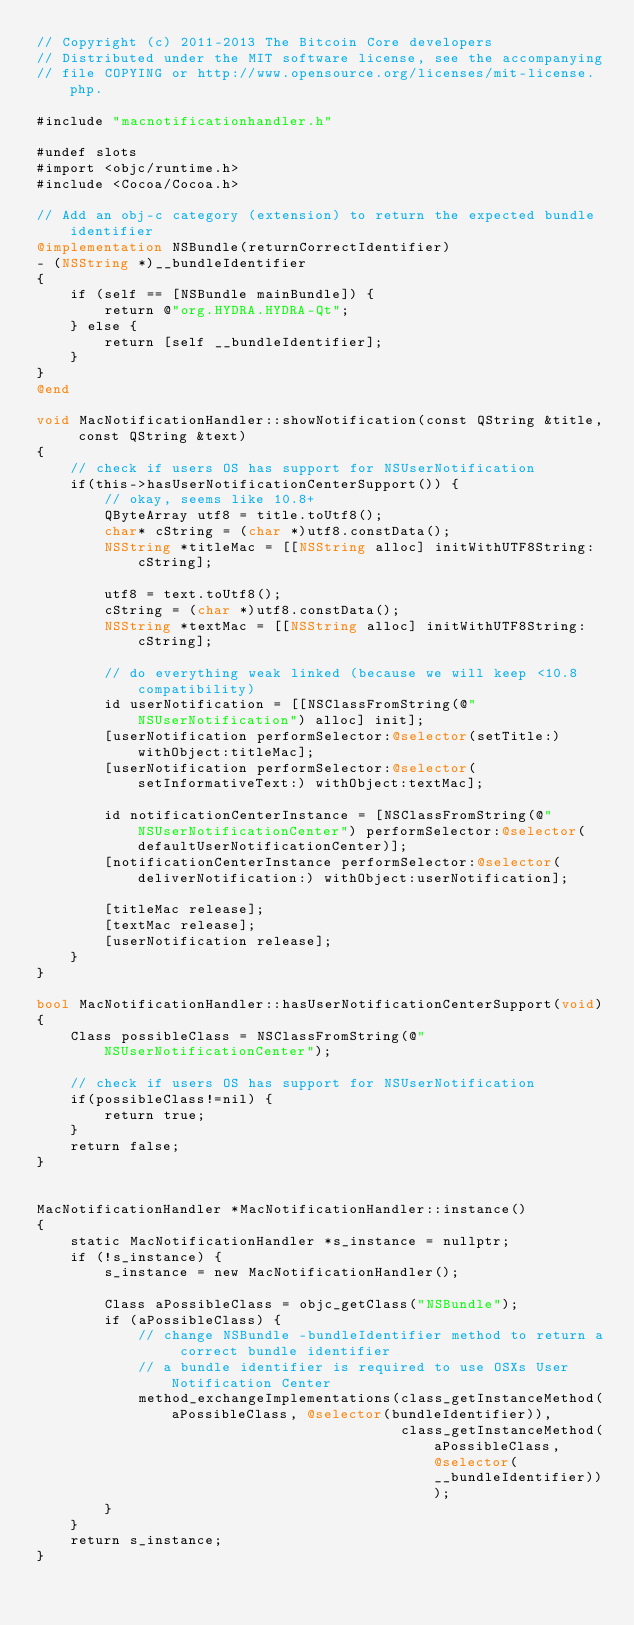Convert code to text. <code><loc_0><loc_0><loc_500><loc_500><_ObjectiveC_>// Copyright (c) 2011-2013 The Bitcoin Core developers
// Distributed under the MIT software license, see the accompanying
// file COPYING or http://www.opensource.org/licenses/mit-license.php.

#include "macnotificationhandler.h"

#undef slots
#import <objc/runtime.h>
#include <Cocoa/Cocoa.h>

// Add an obj-c category (extension) to return the expected bundle identifier
@implementation NSBundle(returnCorrectIdentifier)
- (NSString *)__bundleIdentifier
{
    if (self == [NSBundle mainBundle]) {
        return @"org.HYDRA.HYDRA-Qt";
    } else {
        return [self __bundleIdentifier];
    }
}
@end

void MacNotificationHandler::showNotification(const QString &title, const QString &text)
{
    // check if users OS has support for NSUserNotification
    if(this->hasUserNotificationCenterSupport()) {
        // okay, seems like 10.8+
        QByteArray utf8 = title.toUtf8();
        char* cString = (char *)utf8.constData();
        NSString *titleMac = [[NSString alloc] initWithUTF8String:cString];

        utf8 = text.toUtf8();
        cString = (char *)utf8.constData();
        NSString *textMac = [[NSString alloc] initWithUTF8String:cString];

        // do everything weak linked (because we will keep <10.8 compatibility)
        id userNotification = [[NSClassFromString(@"NSUserNotification") alloc] init];
        [userNotification performSelector:@selector(setTitle:) withObject:titleMac];
        [userNotification performSelector:@selector(setInformativeText:) withObject:textMac];

        id notificationCenterInstance = [NSClassFromString(@"NSUserNotificationCenter") performSelector:@selector(defaultUserNotificationCenter)];
        [notificationCenterInstance performSelector:@selector(deliverNotification:) withObject:userNotification];

        [titleMac release];
        [textMac release];
        [userNotification release];
    }
}

bool MacNotificationHandler::hasUserNotificationCenterSupport(void)
{
    Class possibleClass = NSClassFromString(@"NSUserNotificationCenter");

    // check if users OS has support for NSUserNotification
    if(possibleClass!=nil) {
        return true;
    }
    return false;
}


MacNotificationHandler *MacNotificationHandler::instance()
{
    static MacNotificationHandler *s_instance = nullptr;
    if (!s_instance) {
        s_instance = new MacNotificationHandler();

        Class aPossibleClass = objc_getClass("NSBundle");
        if (aPossibleClass) {
            // change NSBundle -bundleIdentifier method to return a correct bundle identifier
            // a bundle identifier is required to use OSXs User Notification Center
            method_exchangeImplementations(class_getInstanceMethod(aPossibleClass, @selector(bundleIdentifier)),
                                           class_getInstanceMethod(aPossibleClass, @selector(__bundleIdentifier)));
        }
    }
    return s_instance;
}
</code> 